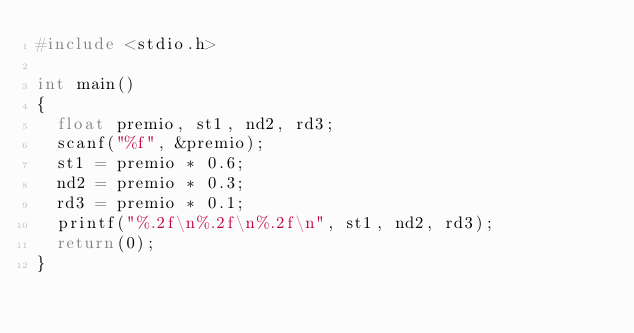Convert code to text. <code><loc_0><loc_0><loc_500><loc_500><_C_>#include <stdio.h>

int main()
{
  float premio, st1, nd2, rd3;
  scanf("%f", &premio);
  st1 = premio * 0.6;
  nd2 = premio * 0.3;
  rd3 = premio * 0.1;
  printf("%.2f\n%.2f\n%.2f\n", st1, nd2, rd3);
  return(0);
}
</code> 